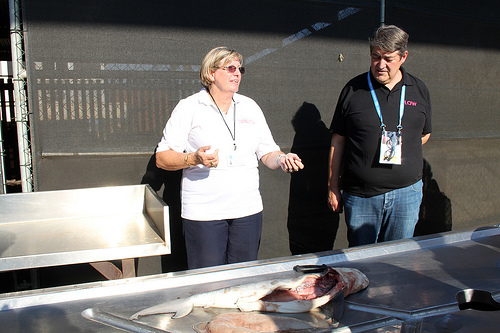<image>
Is there a woman on the table? No. The woman is not positioned on the table. They may be near each other, but the woman is not supported by or resting on top of the table. 